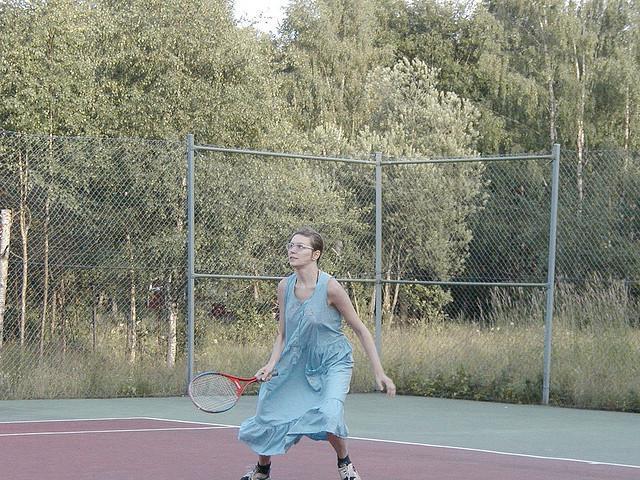How many people are in the photo?
Give a very brief answer. 1. 